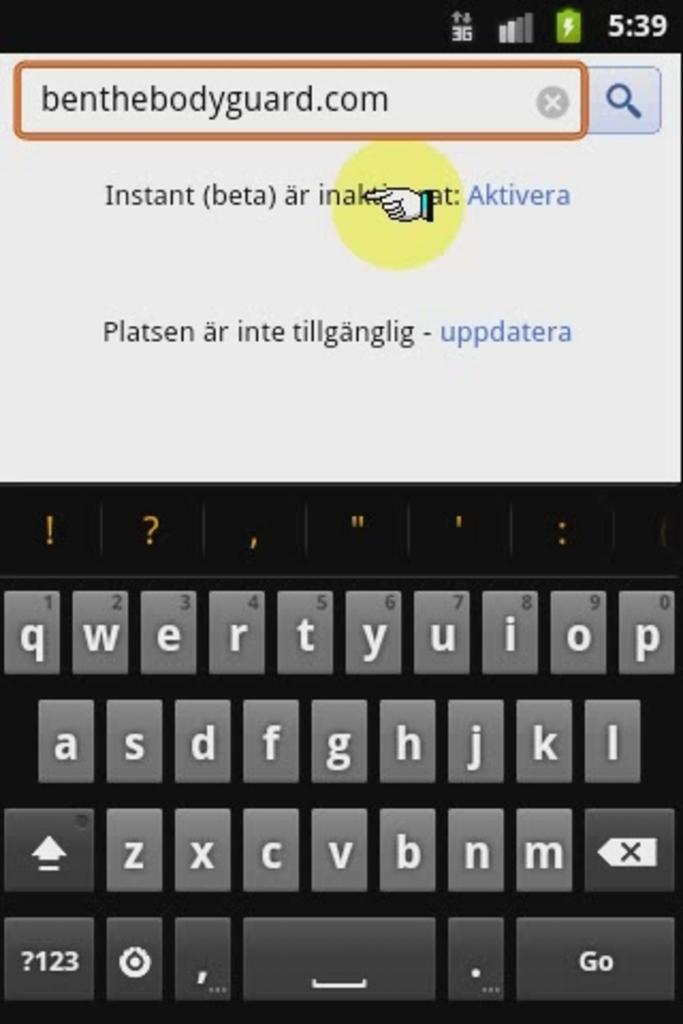<image>
Share a concise interpretation of the image provided. Screenshot of what looks like a blackberry on benthebodyguard.com 